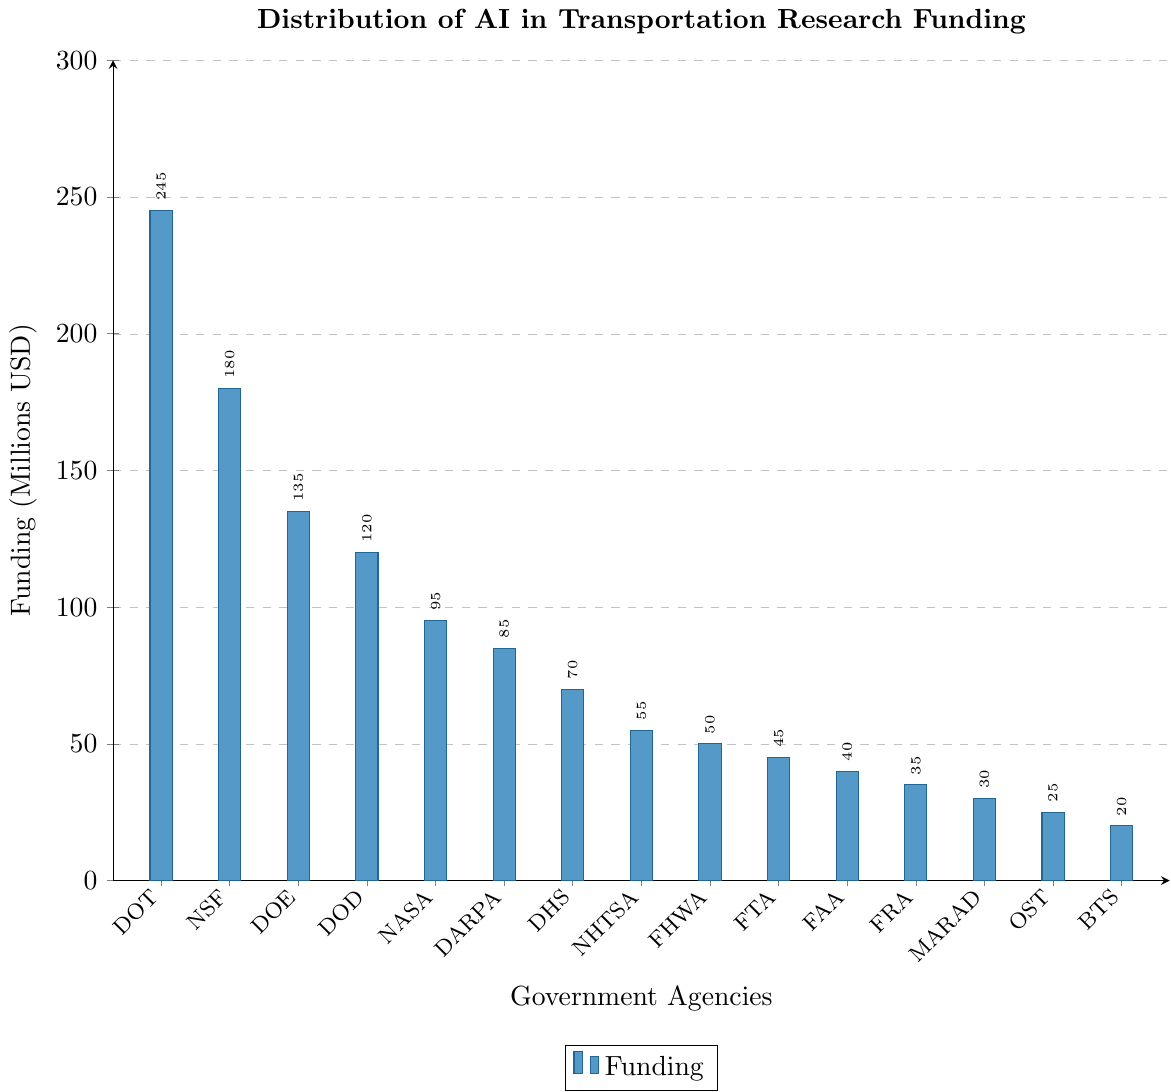What is the total funding provided by the Department of Transportation and the National Science Foundation? Sum the funding amounts for the Department of Transportation (245 million USD) and the National Science Foundation (180 million USD): 245 + 180 = 425 million USD
Answer: 425 million USD Which agency received the least funding, and how much did it receive? The shortest bar corresponds to the Bureau of Transportation Statistics, which received 20 million USD in funding
Answer: Bureau of Transportation Statistics, 20 million USD How does the funding for NASA compare to the funding for DARPA? Compare the height of the bars for NASA (95 million USD) and DARPA (85 million USD). NASA received more funding than DARPA by 10 million USD
Answer: NASA received more funding by 10 million USD What is the average funding across all agencies? Sum all the funding amounts and divide by the number of agencies. Total funding is 1,330 million USD (245 + 180 + 135 + 120 + 95 + 85 + 70 + 55 + 50 + 45 + 40 + 35 + 30 + 25 + 20). Number of agencies is 15. Average funding = 1,330 / 15 = 88.67 million USD
Answer: 88.67 million USD What percentage of the total funding did the Department of Defense receive? First, calculate the total funding, which is 1,330 million USD. Then, divide the funding for the Department of Defense (120 million USD) by the total funding and multiply by 100 to get the percentage: (120 / 1,330) * 100 ≈ 9.02%
Answer: 9.02% Identify the agency with the second highest funding and state the amount. The agency with the second highest funding is the National Science Foundation, which received 180 million USD
Answer: National Science Foundation, 180 million USD How much more funding did the Department of Transportation receive compared to the Department of Energy? Subtract the funding of the Department of Energy (135 million USD) from the funding of the Department of Transportation (245 million USD): 245 - 135 = 110 million USD
Answer: 110 million USD What is the combined funding for the Federal Highway Administration and the Federal Transit Administration? Sum the funding amounts for the Federal Highway Administration (50 million USD) and the Federal Transit Administration (45 million USD): 50 + 45 = 95 million USD
Answer: 95 million USD If you combine the funding of NASA, DARPA, and the Department of Homeland Security, would it exceed the funding given to the Department of Transportation? Sum the funding for NASA (95 million USD), DARPA (85 million USD), and the Department of Homeland Security (70 million USD): 95 + 85 + 70 = 250 million USD. Since 250 million USD is greater than 245 million USD, the combined funding exceeds the funding given to the Department of Transportation
Answer: Yes By how much does the funding for the National Science Foundation exceed the average funding across all agencies? Calculate the difference between the funding for the National Science Foundation (180 million USD) and the average funding (88.67 million USD): 180 - 88.67 = 91.33 million USD
Answer: 91.33 million USD 